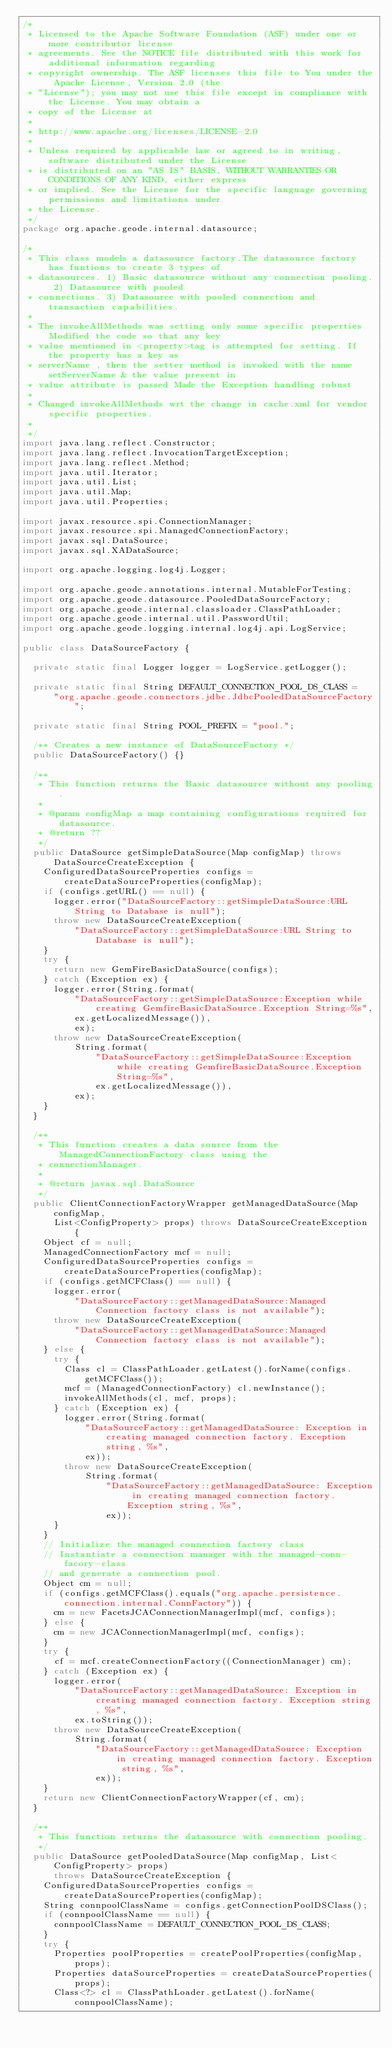Convert code to text. <code><loc_0><loc_0><loc_500><loc_500><_Java_>/*
 * Licensed to the Apache Software Foundation (ASF) under one or more contributor license
 * agreements. See the NOTICE file distributed with this work for additional information regarding
 * copyright ownership. The ASF licenses this file to You under the Apache License, Version 2.0 (the
 * "License"); you may not use this file except in compliance with the License. You may obtain a
 * copy of the License at
 *
 * http://www.apache.org/licenses/LICENSE-2.0
 *
 * Unless required by applicable law or agreed to in writing, software distributed under the License
 * is distributed on an "AS IS" BASIS, WITHOUT WARRANTIES OR CONDITIONS OF ANY KIND, either express
 * or implied. See the License for the specific language governing permissions and limitations under
 * the License.
 */
package org.apache.geode.internal.datasource;

/*
 * This class models a datasource factory.The datasource factory has funtions to create 3 types of
 * datasources. 1) Basic datasource without any connection pooling. 2) Datasource with pooled
 * connections. 3) Datasource with pooled connection and transaction capabilities.
 *
 * The invokeAllMethods was setting only some specific properties Modified the code so that any key
 * value mentioned in <property>tag is attempted for setting. If the property has a key as
 * serverName , then the setter method is invoked with the name setServerName & the value present in
 * value attribute is passed Made the Exception handling robust
 *
 * Changed invokeAllMethods wrt the change in cache.xml for vendor specific properties.
 *
 */
import java.lang.reflect.Constructor;
import java.lang.reflect.InvocationTargetException;
import java.lang.reflect.Method;
import java.util.Iterator;
import java.util.List;
import java.util.Map;
import java.util.Properties;

import javax.resource.spi.ConnectionManager;
import javax.resource.spi.ManagedConnectionFactory;
import javax.sql.DataSource;
import javax.sql.XADataSource;

import org.apache.logging.log4j.Logger;

import org.apache.geode.annotations.internal.MutableForTesting;
import org.apache.geode.datasource.PooledDataSourceFactory;
import org.apache.geode.internal.classloader.ClassPathLoader;
import org.apache.geode.internal.util.PasswordUtil;
import org.apache.geode.logging.internal.log4j.api.LogService;

public class DataSourceFactory {

  private static final Logger logger = LogService.getLogger();

  private static final String DEFAULT_CONNECTION_POOL_DS_CLASS =
      "org.apache.geode.connectors.jdbc.JdbcPooledDataSourceFactory";

  private static final String POOL_PREFIX = "pool.";

  /** Creates a new instance of DataSourceFactory */
  public DataSourceFactory() {}

  /**
   * This function returns the Basic datasource without any pooling.
   *
   * @param configMap a map containing configurations required for datasource.
   * @return ??
   */
  public DataSource getSimpleDataSource(Map configMap) throws DataSourceCreateException {
    ConfiguredDataSourceProperties configs = createDataSourceProperties(configMap);
    if (configs.getURL() == null) {
      logger.error("DataSourceFactory::getSimpleDataSource:URL String to Database is null");
      throw new DataSourceCreateException(
          "DataSourceFactory::getSimpleDataSource:URL String to Database is null");
    }
    try {
      return new GemFireBasicDataSource(configs);
    } catch (Exception ex) {
      logger.error(String.format(
          "DataSourceFactory::getSimpleDataSource:Exception while creating GemfireBasicDataSource.Exception String=%s",
          ex.getLocalizedMessage()),
          ex);
      throw new DataSourceCreateException(
          String.format(
              "DataSourceFactory::getSimpleDataSource:Exception while creating GemfireBasicDataSource.Exception String=%s",
              ex.getLocalizedMessage()),
          ex);
    }
  }

  /**
   * This function creates a data source from the ManagedConnectionFactory class using the
   * connectionManager.
   *
   * @return javax.sql.DataSource
   */
  public ClientConnectionFactoryWrapper getManagedDataSource(Map configMap,
      List<ConfigProperty> props) throws DataSourceCreateException {
    Object cf = null;
    ManagedConnectionFactory mcf = null;
    ConfiguredDataSourceProperties configs = createDataSourceProperties(configMap);
    if (configs.getMCFClass() == null) {
      logger.error(
          "DataSourceFactory::getManagedDataSource:Managed Connection factory class is not available");
      throw new DataSourceCreateException(
          "DataSourceFactory::getManagedDataSource:Managed Connection factory class is not available");
    } else {
      try {
        Class cl = ClassPathLoader.getLatest().forName(configs.getMCFClass());
        mcf = (ManagedConnectionFactory) cl.newInstance();
        invokeAllMethods(cl, mcf, props);
      } catch (Exception ex) {
        logger.error(String.format(
            "DataSourceFactory::getManagedDataSource: Exception in creating managed connection factory. Exception string, %s",
            ex));
        throw new DataSourceCreateException(
            String.format(
                "DataSourceFactory::getManagedDataSource: Exception in creating managed connection factory. Exception string, %s",
                ex));
      }
    }
    // Initialize the managed connection factory class
    // Instantiate a connection manager with the managed-conn-facory-class
    // and generate a connection pool.
    Object cm = null;
    if (configs.getMCFClass().equals("org.apache.persistence.connection.internal.ConnFactory")) {
      cm = new FacetsJCAConnectionManagerImpl(mcf, configs);
    } else {
      cm = new JCAConnectionManagerImpl(mcf, configs);
    }
    try {
      cf = mcf.createConnectionFactory((ConnectionManager) cm);
    } catch (Exception ex) {
      logger.error(
          "DataSourceFactory::getManagedDataSource: Exception in creating managed connection factory. Exception string, %s",
          ex.toString());
      throw new DataSourceCreateException(
          String.format(
              "DataSourceFactory::getManagedDataSource: Exception in creating managed connection factory. Exception string, %s",
              ex));
    }
    return new ClientConnectionFactoryWrapper(cf, cm);
  }

  /**
   * This function returns the datasource with connection pooling.
   */
  public DataSource getPooledDataSource(Map configMap, List<ConfigProperty> props)
      throws DataSourceCreateException {
    ConfiguredDataSourceProperties configs = createDataSourceProperties(configMap);
    String connpoolClassName = configs.getConnectionPoolDSClass();
    if (connpoolClassName == null) {
      connpoolClassName = DEFAULT_CONNECTION_POOL_DS_CLASS;
    }
    try {
      Properties poolProperties = createPoolProperties(configMap, props);
      Properties dataSourceProperties = createDataSourceProperties(props);
      Class<?> cl = ClassPathLoader.getLatest().forName(connpoolClassName);</code> 